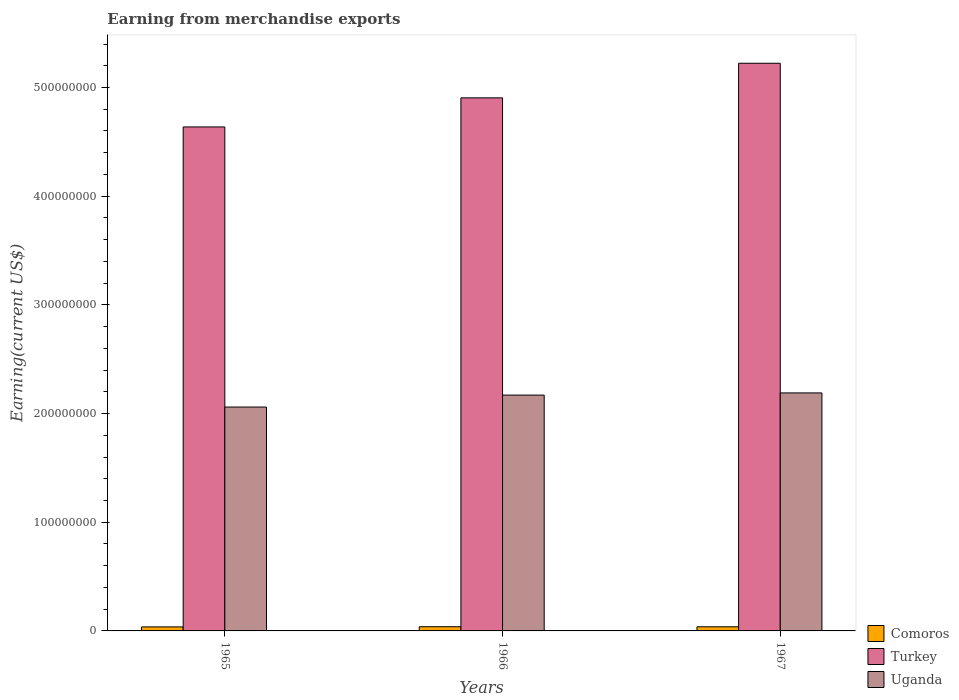How many different coloured bars are there?
Provide a succinct answer. 3. How many groups of bars are there?
Provide a succinct answer. 3. Are the number of bars per tick equal to the number of legend labels?
Your response must be concise. Yes. How many bars are there on the 3rd tick from the left?
Provide a short and direct response. 3. What is the label of the 3rd group of bars from the left?
Provide a succinct answer. 1967. In how many cases, is the number of bars for a given year not equal to the number of legend labels?
Give a very brief answer. 0. What is the amount earned from merchandise exports in Comoros in 1966?
Offer a terse response. 3.86e+06. Across all years, what is the maximum amount earned from merchandise exports in Turkey?
Provide a succinct answer. 5.22e+08. Across all years, what is the minimum amount earned from merchandise exports in Turkey?
Ensure brevity in your answer.  4.64e+08. In which year was the amount earned from merchandise exports in Uganda maximum?
Your response must be concise. 1967. In which year was the amount earned from merchandise exports in Comoros minimum?
Your answer should be very brief. 1965. What is the total amount earned from merchandise exports in Turkey in the graph?
Provide a succinct answer. 1.48e+09. What is the difference between the amount earned from merchandise exports in Uganda in 1965 and that in 1966?
Provide a short and direct response. -1.10e+07. What is the difference between the amount earned from merchandise exports in Turkey in 1965 and the amount earned from merchandise exports in Comoros in 1967?
Your answer should be compact. 4.60e+08. What is the average amount earned from merchandise exports in Uganda per year?
Your answer should be very brief. 2.14e+08. In the year 1967, what is the difference between the amount earned from merchandise exports in Uganda and amount earned from merchandise exports in Turkey?
Provide a succinct answer. -3.03e+08. In how many years, is the amount earned from merchandise exports in Turkey greater than 320000000 US$?
Ensure brevity in your answer.  3. What is the ratio of the amount earned from merchandise exports in Uganda in 1965 to that in 1966?
Provide a succinct answer. 0.95. Is the amount earned from merchandise exports in Uganda in 1965 less than that in 1966?
Provide a succinct answer. Yes. Is the difference between the amount earned from merchandise exports in Uganda in 1965 and 1967 greater than the difference between the amount earned from merchandise exports in Turkey in 1965 and 1967?
Provide a short and direct response. Yes. What is the difference between the highest and the second highest amount earned from merchandise exports in Comoros?
Keep it short and to the point. 6.08e+04. What is the difference between the highest and the lowest amount earned from merchandise exports in Turkey?
Offer a very short reply. 5.86e+07. In how many years, is the amount earned from merchandise exports in Comoros greater than the average amount earned from merchandise exports in Comoros taken over all years?
Ensure brevity in your answer.  2. Is it the case that in every year, the sum of the amount earned from merchandise exports in Comoros and amount earned from merchandise exports in Uganda is greater than the amount earned from merchandise exports in Turkey?
Offer a very short reply. No. Are all the bars in the graph horizontal?
Provide a short and direct response. No. How many years are there in the graph?
Your response must be concise. 3. Are the values on the major ticks of Y-axis written in scientific E-notation?
Provide a short and direct response. No. Does the graph contain grids?
Your answer should be compact. No. Where does the legend appear in the graph?
Make the answer very short. Bottom right. How many legend labels are there?
Offer a very short reply. 3. How are the legend labels stacked?
Keep it short and to the point. Vertical. What is the title of the graph?
Provide a short and direct response. Earning from merchandise exports. What is the label or title of the Y-axis?
Ensure brevity in your answer.  Earning(current US$). What is the Earning(current US$) of Comoros in 1965?
Provide a short and direct response. 3.71e+06. What is the Earning(current US$) of Turkey in 1965?
Your answer should be very brief. 4.64e+08. What is the Earning(current US$) in Uganda in 1965?
Your response must be concise. 2.06e+08. What is the Earning(current US$) in Comoros in 1966?
Offer a very short reply. 3.86e+06. What is the Earning(current US$) in Turkey in 1966?
Keep it short and to the point. 4.90e+08. What is the Earning(current US$) of Uganda in 1966?
Provide a succinct answer. 2.17e+08. What is the Earning(current US$) of Comoros in 1967?
Your response must be concise. 3.80e+06. What is the Earning(current US$) in Turkey in 1967?
Offer a terse response. 5.22e+08. What is the Earning(current US$) in Uganda in 1967?
Give a very brief answer. 2.19e+08. Across all years, what is the maximum Earning(current US$) of Comoros?
Offer a terse response. 3.86e+06. Across all years, what is the maximum Earning(current US$) of Turkey?
Make the answer very short. 5.22e+08. Across all years, what is the maximum Earning(current US$) of Uganda?
Offer a very short reply. 2.19e+08. Across all years, what is the minimum Earning(current US$) in Comoros?
Provide a short and direct response. 3.71e+06. Across all years, what is the minimum Earning(current US$) of Turkey?
Make the answer very short. 4.64e+08. Across all years, what is the minimum Earning(current US$) in Uganda?
Provide a succinct answer. 2.06e+08. What is the total Earning(current US$) of Comoros in the graph?
Your response must be concise. 1.14e+07. What is the total Earning(current US$) in Turkey in the graph?
Keep it short and to the point. 1.48e+09. What is the total Earning(current US$) of Uganda in the graph?
Give a very brief answer. 6.42e+08. What is the difference between the Earning(current US$) of Comoros in 1965 and that in 1966?
Provide a short and direct response. -1.54e+05. What is the difference between the Earning(current US$) of Turkey in 1965 and that in 1966?
Your response must be concise. -2.68e+07. What is the difference between the Earning(current US$) in Uganda in 1965 and that in 1966?
Provide a succinct answer. -1.10e+07. What is the difference between the Earning(current US$) of Comoros in 1965 and that in 1967?
Make the answer very short. -9.32e+04. What is the difference between the Earning(current US$) in Turkey in 1965 and that in 1967?
Provide a short and direct response. -5.86e+07. What is the difference between the Earning(current US$) in Uganda in 1965 and that in 1967?
Provide a short and direct response. -1.30e+07. What is the difference between the Earning(current US$) of Comoros in 1966 and that in 1967?
Keep it short and to the point. 6.08e+04. What is the difference between the Earning(current US$) in Turkey in 1966 and that in 1967?
Offer a very short reply. -3.18e+07. What is the difference between the Earning(current US$) in Comoros in 1965 and the Earning(current US$) in Turkey in 1966?
Offer a very short reply. -4.87e+08. What is the difference between the Earning(current US$) of Comoros in 1965 and the Earning(current US$) of Uganda in 1966?
Your response must be concise. -2.13e+08. What is the difference between the Earning(current US$) in Turkey in 1965 and the Earning(current US$) in Uganda in 1966?
Keep it short and to the point. 2.47e+08. What is the difference between the Earning(current US$) of Comoros in 1965 and the Earning(current US$) of Turkey in 1967?
Provide a succinct answer. -5.19e+08. What is the difference between the Earning(current US$) in Comoros in 1965 and the Earning(current US$) in Uganda in 1967?
Your response must be concise. -2.15e+08. What is the difference between the Earning(current US$) of Turkey in 1965 and the Earning(current US$) of Uganda in 1967?
Your answer should be very brief. 2.45e+08. What is the difference between the Earning(current US$) in Comoros in 1966 and the Earning(current US$) in Turkey in 1967?
Keep it short and to the point. -5.18e+08. What is the difference between the Earning(current US$) in Comoros in 1966 and the Earning(current US$) in Uganda in 1967?
Ensure brevity in your answer.  -2.15e+08. What is the difference between the Earning(current US$) in Turkey in 1966 and the Earning(current US$) in Uganda in 1967?
Your response must be concise. 2.72e+08. What is the average Earning(current US$) in Comoros per year?
Ensure brevity in your answer.  3.79e+06. What is the average Earning(current US$) of Turkey per year?
Your response must be concise. 4.92e+08. What is the average Earning(current US$) of Uganda per year?
Your response must be concise. 2.14e+08. In the year 1965, what is the difference between the Earning(current US$) in Comoros and Earning(current US$) in Turkey?
Make the answer very short. -4.60e+08. In the year 1965, what is the difference between the Earning(current US$) in Comoros and Earning(current US$) in Uganda?
Provide a short and direct response. -2.02e+08. In the year 1965, what is the difference between the Earning(current US$) of Turkey and Earning(current US$) of Uganda?
Your answer should be very brief. 2.58e+08. In the year 1966, what is the difference between the Earning(current US$) in Comoros and Earning(current US$) in Turkey?
Your answer should be compact. -4.87e+08. In the year 1966, what is the difference between the Earning(current US$) in Comoros and Earning(current US$) in Uganda?
Offer a very short reply. -2.13e+08. In the year 1966, what is the difference between the Earning(current US$) in Turkey and Earning(current US$) in Uganda?
Give a very brief answer. 2.74e+08. In the year 1967, what is the difference between the Earning(current US$) in Comoros and Earning(current US$) in Turkey?
Provide a short and direct response. -5.19e+08. In the year 1967, what is the difference between the Earning(current US$) of Comoros and Earning(current US$) of Uganda?
Keep it short and to the point. -2.15e+08. In the year 1967, what is the difference between the Earning(current US$) of Turkey and Earning(current US$) of Uganda?
Make the answer very short. 3.03e+08. What is the ratio of the Earning(current US$) in Comoros in 1965 to that in 1966?
Keep it short and to the point. 0.96. What is the ratio of the Earning(current US$) in Turkey in 1965 to that in 1966?
Your answer should be compact. 0.95. What is the ratio of the Earning(current US$) of Uganda in 1965 to that in 1966?
Keep it short and to the point. 0.95. What is the ratio of the Earning(current US$) of Comoros in 1965 to that in 1967?
Provide a short and direct response. 0.98. What is the ratio of the Earning(current US$) of Turkey in 1965 to that in 1967?
Ensure brevity in your answer.  0.89. What is the ratio of the Earning(current US$) of Uganda in 1965 to that in 1967?
Keep it short and to the point. 0.94. What is the ratio of the Earning(current US$) of Comoros in 1966 to that in 1967?
Give a very brief answer. 1.02. What is the ratio of the Earning(current US$) in Turkey in 1966 to that in 1967?
Provide a short and direct response. 0.94. What is the ratio of the Earning(current US$) in Uganda in 1966 to that in 1967?
Give a very brief answer. 0.99. What is the difference between the highest and the second highest Earning(current US$) in Comoros?
Offer a terse response. 6.08e+04. What is the difference between the highest and the second highest Earning(current US$) in Turkey?
Offer a terse response. 3.18e+07. What is the difference between the highest and the second highest Earning(current US$) of Uganda?
Your answer should be compact. 2.00e+06. What is the difference between the highest and the lowest Earning(current US$) in Comoros?
Offer a very short reply. 1.54e+05. What is the difference between the highest and the lowest Earning(current US$) of Turkey?
Your answer should be compact. 5.86e+07. What is the difference between the highest and the lowest Earning(current US$) in Uganda?
Give a very brief answer. 1.30e+07. 